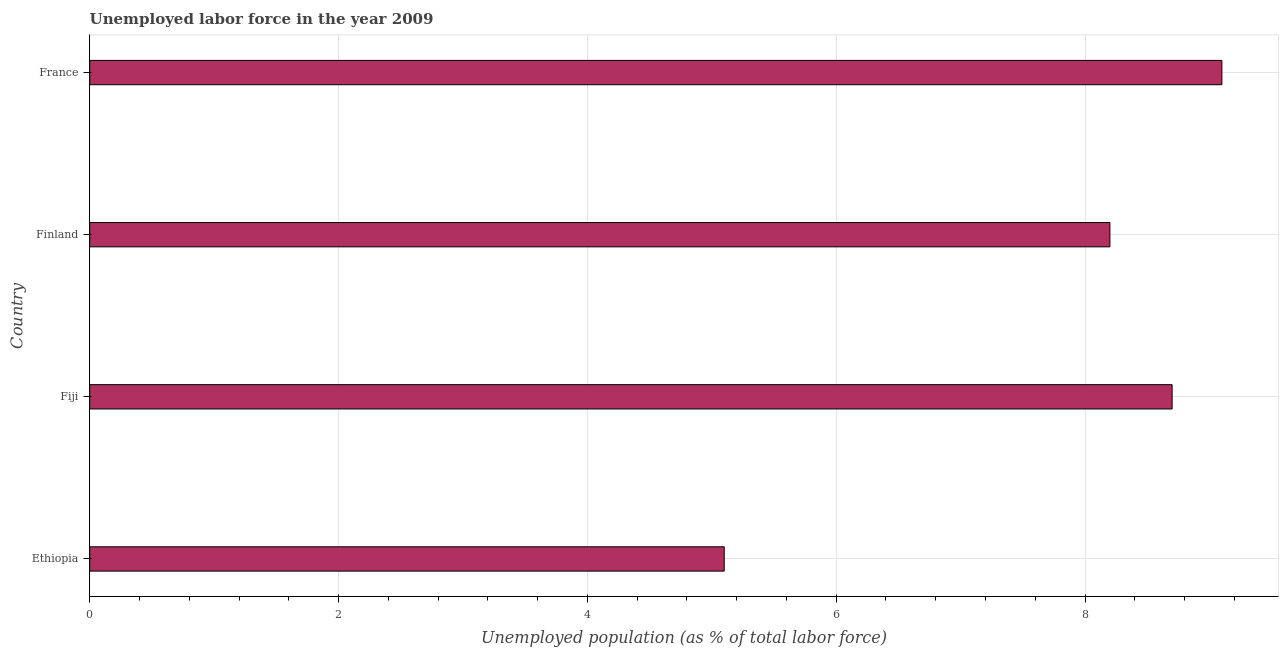What is the title of the graph?
Provide a succinct answer. Unemployed labor force in the year 2009. What is the label or title of the X-axis?
Offer a very short reply. Unemployed population (as % of total labor force). What is the label or title of the Y-axis?
Your response must be concise. Country. What is the total unemployed population in Fiji?
Provide a succinct answer. 8.7. Across all countries, what is the maximum total unemployed population?
Make the answer very short. 9.1. Across all countries, what is the minimum total unemployed population?
Provide a short and direct response. 5.1. In which country was the total unemployed population minimum?
Provide a short and direct response. Ethiopia. What is the sum of the total unemployed population?
Give a very brief answer. 31.1. What is the difference between the total unemployed population in Ethiopia and Fiji?
Ensure brevity in your answer.  -3.6. What is the average total unemployed population per country?
Your response must be concise. 7.78. What is the median total unemployed population?
Give a very brief answer. 8.45. What is the ratio of the total unemployed population in Fiji to that in Finland?
Your answer should be compact. 1.06. What is the difference between the highest and the second highest total unemployed population?
Offer a terse response. 0.4. Is the sum of the total unemployed population in Fiji and France greater than the maximum total unemployed population across all countries?
Give a very brief answer. Yes. What is the difference between the highest and the lowest total unemployed population?
Provide a succinct answer. 4. In how many countries, is the total unemployed population greater than the average total unemployed population taken over all countries?
Ensure brevity in your answer.  3. How many bars are there?
Provide a succinct answer. 4. What is the difference between two consecutive major ticks on the X-axis?
Provide a succinct answer. 2. What is the Unemployed population (as % of total labor force) of Ethiopia?
Offer a very short reply. 5.1. What is the Unemployed population (as % of total labor force) of Fiji?
Make the answer very short. 8.7. What is the Unemployed population (as % of total labor force) of Finland?
Provide a short and direct response. 8.2. What is the Unemployed population (as % of total labor force) in France?
Provide a short and direct response. 9.1. What is the difference between the Unemployed population (as % of total labor force) in Ethiopia and Finland?
Ensure brevity in your answer.  -3.1. What is the difference between the Unemployed population (as % of total labor force) in Ethiopia and France?
Keep it short and to the point. -4. What is the difference between the Unemployed population (as % of total labor force) in Fiji and Finland?
Your answer should be very brief. 0.5. What is the difference between the Unemployed population (as % of total labor force) in Finland and France?
Your answer should be compact. -0.9. What is the ratio of the Unemployed population (as % of total labor force) in Ethiopia to that in Fiji?
Give a very brief answer. 0.59. What is the ratio of the Unemployed population (as % of total labor force) in Ethiopia to that in Finland?
Offer a very short reply. 0.62. What is the ratio of the Unemployed population (as % of total labor force) in Ethiopia to that in France?
Your answer should be very brief. 0.56. What is the ratio of the Unemployed population (as % of total labor force) in Fiji to that in Finland?
Ensure brevity in your answer.  1.06. What is the ratio of the Unemployed population (as % of total labor force) in Fiji to that in France?
Provide a short and direct response. 0.96. What is the ratio of the Unemployed population (as % of total labor force) in Finland to that in France?
Keep it short and to the point. 0.9. 